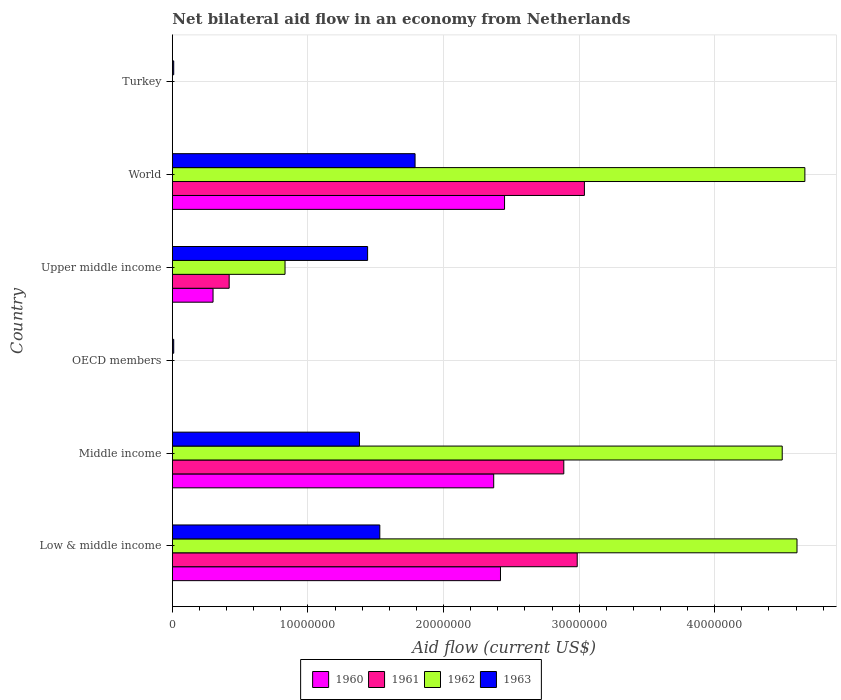How many different coloured bars are there?
Make the answer very short. 4. Are the number of bars on each tick of the Y-axis equal?
Give a very brief answer. No. How many bars are there on the 3rd tick from the bottom?
Offer a terse response. 1. What is the label of the 4th group of bars from the top?
Your response must be concise. OECD members. Across all countries, what is the maximum net bilateral aid flow in 1960?
Make the answer very short. 2.45e+07. Across all countries, what is the minimum net bilateral aid flow in 1960?
Provide a succinct answer. 0. In which country was the net bilateral aid flow in 1963 maximum?
Provide a short and direct response. World. What is the total net bilateral aid flow in 1960 in the graph?
Give a very brief answer. 7.54e+07. What is the difference between the net bilateral aid flow in 1963 in OECD members and that in Turkey?
Your answer should be very brief. 0. What is the difference between the net bilateral aid flow in 1963 in OECD members and the net bilateral aid flow in 1962 in Turkey?
Your response must be concise. 1.00e+05. What is the average net bilateral aid flow in 1961 per country?
Offer a terse response. 1.56e+07. What is the difference between the net bilateral aid flow in 1963 and net bilateral aid flow in 1960 in World?
Your response must be concise. -6.60e+06. In how many countries, is the net bilateral aid flow in 1962 greater than 34000000 US$?
Make the answer very short. 3. What is the ratio of the net bilateral aid flow in 1962 in Middle income to that in World?
Your answer should be very brief. 0.96. Is the net bilateral aid flow in 1962 in Low & middle income less than that in Upper middle income?
Your answer should be very brief. No. Is the difference between the net bilateral aid flow in 1963 in Middle income and World greater than the difference between the net bilateral aid flow in 1960 in Middle income and World?
Keep it short and to the point. No. What is the difference between the highest and the lowest net bilateral aid flow in 1962?
Your response must be concise. 4.66e+07. In how many countries, is the net bilateral aid flow in 1963 greater than the average net bilateral aid flow in 1963 taken over all countries?
Your answer should be compact. 4. Is it the case that in every country, the sum of the net bilateral aid flow in 1962 and net bilateral aid flow in 1960 is greater than the net bilateral aid flow in 1961?
Provide a succinct answer. No. How many bars are there?
Make the answer very short. 18. Are all the bars in the graph horizontal?
Offer a very short reply. Yes. Are the values on the major ticks of X-axis written in scientific E-notation?
Provide a succinct answer. No. Does the graph contain any zero values?
Offer a terse response. Yes. How are the legend labels stacked?
Provide a succinct answer. Horizontal. What is the title of the graph?
Your answer should be compact. Net bilateral aid flow in an economy from Netherlands. Does "1984" appear as one of the legend labels in the graph?
Make the answer very short. No. What is the Aid flow (current US$) in 1960 in Low & middle income?
Give a very brief answer. 2.42e+07. What is the Aid flow (current US$) of 1961 in Low & middle income?
Offer a very short reply. 2.99e+07. What is the Aid flow (current US$) in 1962 in Low & middle income?
Offer a very short reply. 4.61e+07. What is the Aid flow (current US$) of 1963 in Low & middle income?
Keep it short and to the point. 1.53e+07. What is the Aid flow (current US$) in 1960 in Middle income?
Ensure brevity in your answer.  2.37e+07. What is the Aid flow (current US$) of 1961 in Middle income?
Keep it short and to the point. 2.89e+07. What is the Aid flow (current US$) in 1962 in Middle income?
Ensure brevity in your answer.  4.50e+07. What is the Aid flow (current US$) of 1963 in Middle income?
Give a very brief answer. 1.38e+07. What is the Aid flow (current US$) in 1960 in OECD members?
Ensure brevity in your answer.  0. What is the Aid flow (current US$) in 1961 in OECD members?
Provide a short and direct response. 0. What is the Aid flow (current US$) of 1962 in OECD members?
Ensure brevity in your answer.  0. What is the Aid flow (current US$) of 1963 in OECD members?
Ensure brevity in your answer.  1.00e+05. What is the Aid flow (current US$) of 1961 in Upper middle income?
Give a very brief answer. 4.19e+06. What is the Aid flow (current US$) in 1962 in Upper middle income?
Your response must be concise. 8.31e+06. What is the Aid flow (current US$) of 1963 in Upper middle income?
Your answer should be very brief. 1.44e+07. What is the Aid flow (current US$) of 1960 in World?
Your response must be concise. 2.45e+07. What is the Aid flow (current US$) of 1961 in World?
Your response must be concise. 3.04e+07. What is the Aid flow (current US$) in 1962 in World?
Your answer should be very brief. 4.66e+07. What is the Aid flow (current US$) in 1963 in World?
Provide a succinct answer. 1.79e+07. What is the Aid flow (current US$) of 1961 in Turkey?
Your response must be concise. 0. What is the Aid flow (current US$) in 1962 in Turkey?
Give a very brief answer. 0. What is the Aid flow (current US$) of 1963 in Turkey?
Ensure brevity in your answer.  1.00e+05. Across all countries, what is the maximum Aid flow (current US$) in 1960?
Your answer should be very brief. 2.45e+07. Across all countries, what is the maximum Aid flow (current US$) of 1961?
Provide a succinct answer. 3.04e+07. Across all countries, what is the maximum Aid flow (current US$) of 1962?
Give a very brief answer. 4.66e+07. Across all countries, what is the maximum Aid flow (current US$) of 1963?
Ensure brevity in your answer.  1.79e+07. What is the total Aid flow (current US$) in 1960 in the graph?
Offer a very short reply. 7.54e+07. What is the total Aid flow (current US$) in 1961 in the graph?
Offer a terse response. 9.33e+07. What is the total Aid flow (current US$) in 1962 in the graph?
Offer a very short reply. 1.46e+08. What is the total Aid flow (current US$) in 1963 in the graph?
Provide a succinct answer. 6.16e+07. What is the difference between the Aid flow (current US$) of 1961 in Low & middle income and that in Middle income?
Keep it short and to the point. 9.90e+05. What is the difference between the Aid flow (current US$) in 1962 in Low & middle income and that in Middle income?
Your answer should be compact. 1.09e+06. What is the difference between the Aid flow (current US$) of 1963 in Low & middle income and that in Middle income?
Make the answer very short. 1.50e+06. What is the difference between the Aid flow (current US$) of 1963 in Low & middle income and that in OECD members?
Offer a very short reply. 1.52e+07. What is the difference between the Aid flow (current US$) in 1960 in Low & middle income and that in Upper middle income?
Offer a terse response. 2.12e+07. What is the difference between the Aid flow (current US$) in 1961 in Low & middle income and that in Upper middle income?
Make the answer very short. 2.57e+07. What is the difference between the Aid flow (current US$) in 1962 in Low & middle income and that in Upper middle income?
Offer a terse response. 3.78e+07. What is the difference between the Aid flow (current US$) in 1963 in Low & middle income and that in Upper middle income?
Offer a very short reply. 9.00e+05. What is the difference between the Aid flow (current US$) of 1961 in Low & middle income and that in World?
Your answer should be very brief. -5.30e+05. What is the difference between the Aid flow (current US$) in 1962 in Low & middle income and that in World?
Keep it short and to the point. -5.80e+05. What is the difference between the Aid flow (current US$) of 1963 in Low & middle income and that in World?
Give a very brief answer. -2.60e+06. What is the difference between the Aid flow (current US$) of 1963 in Low & middle income and that in Turkey?
Give a very brief answer. 1.52e+07. What is the difference between the Aid flow (current US$) in 1963 in Middle income and that in OECD members?
Provide a succinct answer. 1.37e+07. What is the difference between the Aid flow (current US$) of 1960 in Middle income and that in Upper middle income?
Make the answer very short. 2.07e+07. What is the difference between the Aid flow (current US$) in 1961 in Middle income and that in Upper middle income?
Offer a very short reply. 2.47e+07. What is the difference between the Aid flow (current US$) of 1962 in Middle income and that in Upper middle income?
Your answer should be compact. 3.67e+07. What is the difference between the Aid flow (current US$) of 1963 in Middle income and that in Upper middle income?
Offer a very short reply. -6.00e+05. What is the difference between the Aid flow (current US$) in 1960 in Middle income and that in World?
Make the answer very short. -8.00e+05. What is the difference between the Aid flow (current US$) of 1961 in Middle income and that in World?
Provide a succinct answer. -1.52e+06. What is the difference between the Aid flow (current US$) of 1962 in Middle income and that in World?
Keep it short and to the point. -1.67e+06. What is the difference between the Aid flow (current US$) of 1963 in Middle income and that in World?
Your answer should be very brief. -4.10e+06. What is the difference between the Aid flow (current US$) of 1963 in Middle income and that in Turkey?
Provide a short and direct response. 1.37e+07. What is the difference between the Aid flow (current US$) of 1963 in OECD members and that in Upper middle income?
Provide a short and direct response. -1.43e+07. What is the difference between the Aid flow (current US$) in 1963 in OECD members and that in World?
Provide a short and direct response. -1.78e+07. What is the difference between the Aid flow (current US$) of 1963 in OECD members and that in Turkey?
Provide a short and direct response. 0. What is the difference between the Aid flow (current US$) in 1960 in Upper middle income and that in World?
Keep it short and to the point. -2.15e+07. What is the difference between the Aid flow (current US$) of 1961 in Upper middle income and that in World?
Your answer should be compact. -2.62e+07. What is the difference between the Aid flow (current US$) in 1962 in Upper middle income and that in World?
Make the answer very short. -3.83e+07. What is the difference between the Aid flow (current US$) in 1963 in Upper middle income and that in World?
Offer a terse response. -3.50e+06. What is the difference between the Aid flow (current US$) of 1963 in Upper middle income and that in Turkey?
Keep it short and to the point. 1.43e+07. What is the difference between the Aid flow (current US$) in 1963 in World and that in Turkey?
Your response must be concise. 1.78e+07. What is the difference between the Aid flow (current US$) in 1960 in Low & middle income and the Aid flow (current US$) in 1961 in Middle income?
Your answer should be very brief. -4.67e+06. What is the difference between the Aid flow (current US$) of 1960 in Low & middle income and the Aid flow (current US$) of 1962 in Middle income?
Offer a very short reply. -2.08e+07. What is the difference between the Aid flow (current US$) of 1960 in Low & middle income and the Aid flow (current US$) of 1963 in Middle income?
Make the answer very short. 1.04e+07. What is the difference between the Aid flow (current US$) of 1961 in Low & middle income and the Aid flow (current US$) of 1962 in Middle income?
Your response must be concise. -1.51e+07. What is the difference between the Aid flow (current US$) of 1961 in Low & middle income and the Aid flow (current US$) of 1963 in Middle income?
Your answer should be compact. 1.61e+07. What is the difference between the Aid flow (current US$) in 1962 in Low & middle income and the Aid flow (current US$) in 1963 in Middle income?
Make the answer very short. 3.23e+07. What is the difference between the Aid flow (current US$) of 1960 in Low & middle income and the Aid flow (current US$) of 1963 in OECD members?
Provide a succinct answer. 2.41e+07. What is the difference between the Aid flow (current US$) of 1961 in Low & middle income and the Aid flow (current US$) of 1963 in OECD members?
Make the answer very short. 2.98e+07. What is the difference between the Aid flow (current US$) of 1962 in Low & middle income and the Aid flow (current US$) of 1963 in OECD members?
Your answer should be very brief. 4.60e+07. What is the difference between the Aid flow (current US$) of 1960 in Low & middle income and the Aid flow (current US$) of 1961 in Upper middle income?
Ensure brevity in your answer.  2.00e+07. What is the difference between the Aid flow (current US$) of 1960 in Low & middle income and the Aid flow (current US$) of 1962 in Upper middle income?
Offer a very short reply. 1.59e+07. What is the difference between the Aid flow (current US$) in 1960 in Low & middle income and the Aid flow (current US$) in 1963 in Upper middle income?
Ensure brevity in your answer.  9.80e+06. What is the difference between the Aid flow (current US$) in 1961 in Low & middle income and the Aid flow (current US$) in 1962 in Upper middle income?
Your response must be concise. 2.16e+07. What is the difference between the Aid flow (current US$) of 1961 in Low & middle income and the Aid flow (current US$) of 1963 in Upper middle income?
Provide a succinct answer. 1.55e+07. What is the difference between the Aid flow (current US$) in 1962 in Low & middle income and the Aid flow (current US$) in 1963 in Upper middle income?
Keep it short and to the point. 3.17e+07. What is the difference between the Aid flow (current US$) of 1960 in Low & middle income and the Aid flow (current US$) of 1961 in World?
Give a very brief answer. -6.19e+06. What is the difference between the Aid flow (current US$) of 1960 in Low & middle income and the Aid flow (current US$) of 1962 in World?
Keep it short and to the point. -2.24e+07. What is the difference between the Aid flow (current US$) in 1960 in Low & middle income and the Aid flow (current US$) in 1963 in World?
Your answer should be very brief. 6.30e+06. What is the difference between the Aid flow (current US$) in 1961 in Low & middle income and the Aid flow (current US$) in 1962 in World?
Offer a very short reply. -1.68e+07. What is the difference between the Aid flow (current US$) of 1961 in Low & middle income and the Aid flow (current US$) of 1963 in World?
Provide a short and direct response. 1.20e+07. What is the difference between the Aid flow (current US$) of 1962 in Low & middle income and the Aid flow (current US$) of 1963 in World?
Offer a terse response. 2.82e+07. What is the difference between the Aid flow (current US$) of 1960 in Low & middle income and the Aid flow (current US$) of 1963 in Turkey?
Keep it short and to the point. 2.41e+07. What is the difference between the Aid flow (current US$) in 1961 in Low & middle income and the Aid flow (current US$) in 1963 in Turkey?
Provide a short and direct response. 2.98e+07. What is the difference between the Aid flow (current US$) in 1962 in Low & middle income and the Aid flow (current US$) in 1963 in Turkey?
Your answer should be compact. 4.60e+07. What is the difference between the Aid flow (current US$) of 1960 in Middle income and the Aid flow (current US$) of 1963 in OECD members?
Your answer should be compact. 2.36e+07. What is the difference between the Aid flow (current US$) of 1961 in Middle income and the Aid flow (current US$) of 1963 in OECD members?
Make the answer very short. 2.88e+07. What is the difference between the Aid flow (current US$) of 1962 in Middle income and the Aid flow (current US$) of 1963 in OECD members?
Offer a terse response. 4.49e+07. What is the difference between the Aid flow (current US$) of 1960 in Middle income and the Aid flow (current US$) of 1961 in Upper middle income?
Give a very brief answer. 1.95e+07. What is the difference between the Aid flow (current US$) in 1960 in Middle income and the Aid flow (current US$) in 1962 in Upper middle income?
Offer a terse response. 1.54e+07. What is the difference between the Aid flow (current US$) of 1960 in Middle income and the Aid flow (current US$) of 1963 in Upper middle income?
Make the answer very short. 9.30e+06. What is the difference between the Aid flow (current US$) of 1961 in Middle income and the Aid flow (current US$) of 1962 in Upper middle income?
Give a very brief answer. 2.06e+07. What is the difference between the Aid flow (current US$) of 1961 in Middle income and the Aid flow (current US$) of 1963 in Upper middle income?
Provide a short and direct response. 1.45e+07. What is the difference between the Aid flow (current US$) in 1962 in Middle income and the Aid flow (current US$) in 1963 in Upper middle income?
Provide a short and direct response. 3.06e+07. What is the difference between the Aid flow (current US$) of 1960 in Middle income and the Aid flow (current US$) of 1961 in World?
Keep it short and to the point. -6.69e+06. What is the difference between the Aid flow (current US$) of 1960 in Middle income and the Aid flow (current US$) of 1962 in World?
Your response must be concise. -2.30e+07. What is the difference between the Aid flow (current US$) of 1960 in Middle income and the Aid flow (current US$) of 1963 in World?
Provide a short and direct response. 5.80e+06. What is the difference between the Aid flow (current US$) in 1961 in Middle income and the Aid flow (current US$) in 1962 in World?
Make the answer very short. -1.78e+07. What is the difference between the Aid flow (current US$) in 1961 in Middle income and the Aid flow (current US$) in 1963 in World?
Ensure brevity in your answer.  1.10e+07. What is the difference between the Aid flow (current US$) in 1962 in Middle income and the Aid flow (current US$) in 1963 in World?
Give a very brief answer. 2.71e+07. What is the difference between the Aid flow (current US$) in 1960 in Middle income and the Aid flow (current US$) in 1963 in Turkey?
Your answer should be compact. 2.36e+07. What is the difference between the Aid flow (current US$) of 1961 in Middle income and the Aid flow (current US$) of 1963 in Turkey?
Give a very brief answer. 2.88e+07. What is the difference between the Aid flow (current US$) in 1962 in Middle income and the Aid flow (current US$) in 1963 in Turkey?
Offer a very short reply. 4.49e+07. What is the difference between the Aid flow (current US$) of 1960 in Upper middle income and the Aid flow (current US$) of 1961 in World?
Ensure brevity in your answer.  -2.74e+07. What is the difference between the Aid flow (current US$) in 1960 in Upper middle income and the Aid flow (current US$) in 1962 in World?
Your answer should be very brief. -4.36e+07. What is the difference between the Aid flow (current US$) of 1960 in Upper middle income and the Aid flow (current US$) of 1963 in World?
Offer a very short reply. -1.49e+07. What is the difference between the Aid flow (current US$) of 1961 in Upper middle income and the Aid flow (current US$) of 1962 in World?
Give a very brief answer. -4.25e+07. What is the difference between the Aid flow (current US$) in 1961 in Upper middle income and the Aid flow (current US$) in 1963 in World?
Ensure brevity in your answer.  -1.37e+07. What is the difference between the Aid flow (current US$) in 1962 in Upper middle income and the Aid flow (current US$) in 1963 in World?
Provide a short and direct response. -9.59e+06. What is the difference between the Aid flow (current US$) of 1960 in Upper middle income and the Aid flow (current US$) of 1963 in Turkey?
Your answer should be compact. 2.90e+06. What is the difference between the Aid flow (current US$) of 1961 in Upper middle income and the Aid flow (current US$) of 1963 in Turkey?
Offer a terse response. 4.09e+06. What is the difference between the Aid flow (current US$) of 1962 in Upper middle income and the Aid flow (current US$) of 1963 in Turkey?
Provide a succinct answer. 8.21e+06. What is the difference between the Aid flow (current US$) of 1960 in World and the Aid flow (current US$) of 1963 in Turkey?
Your answer should be very brief. 2.44e+07. What is the difference between the Aid flow (current US$) of 1961 in World and the Aid flow (current US$) of 1963 in Turkey?
Provide a short and direct response. 3.03e+07. What is the difference between the Aid flow (current US$) in 1962 in World and the Aid flow (current US$) in 1963 in Turkey?
Your answer should be very brief. 4.66e+07. What is the average Aid flow (current US$) of 1960 per country?
Offer a terse response. 1.26e+07. What is the average Aid flow (current US$) in 1961 per country?
Your answer should be compact. 1.56e+07. What is the average Aid flow (current US$) of 1962 per country?
Give a very brief answer. 2.43e+07. What is the average Aid flow (current US$) of 1963 per country?
Your answer should be very brief. 1.03e+07. What is the difference between the Aid flow (current US$) in 1960 and Aid flow (current US$) in 1961 in Low & middle income?
Your response must be concise. -5.66e+06. What is the difference between the Aid flow (current US$) of 1960 and Aid flow (current US$) of 1962 in Low & middle income?
Offer a terse response. -2.19e+07. What is the difference between the Aid flow (current US$) of 1960 and Aid flow (current US$) of 1963 in Low & middle income?
Ensure brevity in your answer.  8.90e+06. What is the difference between the Aid flow (current US$) in 1961 and Aid flow (current US$) in 1962 in Low & middle income?
Your answer should be very brief. -1.62e+07. What is the difference between the Aid flow (current US$) of 1961 and Aid flow (current US$) of 1963 in Low & middle income?
Keep it short and to the point. 1.46e+07. What is the difference between the Aid flow (current US$) of 1962 and Aid flow (current US$) of 1963 in Low & middle income?
Your answer should be compact. 3.08e+07. What is the difference between the Aid flow (current US$) of 1960 and Aid flow (current US$) of 1961 in Middle income?
Your answer should be very brief. -5.17e+06. What is the difference between the Aid flow (current US$) of 1960 and Aid flow (current US$) of 1962 in Middle income?
Provide a short and direct response. -2.13e+07. What is the difference between the Aid flow (current US$) of 1960 and Aid flow (current US$) of 1963 in Middle income?
Provide a succinct answer. 9.90e+06. What is the difference between the Aid flow (current US$) of 1961 and Aid flow (current US$) of 1962 in Middle income?
Keep it short and to the point. -1.61e+07. What is the difference between the Aid flow (current US$) of 1961 and Aid flow (current US$) of 1963 in Middle income?
Offer a terse response. 1.51e+07. What is the difference between the Aid flow (current US$) of 1962 and Aid flow (current US$) of 1963 in Middle income?
Provide a short and direct response. 3.12e+07. What is the difference between the Aid flow (current US$) of 1960 and Aid flow (current US$) of 1961 in Upper middle income?
Offer a terse response. -1.19e+06. What is the difference between the Aid flow (current US$) of 1960 and Aid flow (current US$) of 1962 in Upper middle income?
Provide a succinct answer. -5.31e+06. What is the difference between the Aid flow (current US$) of 1960 and Aid flow (current US$) of 1963 in Upper middle income?
Make the answer very short. -1.14e+07. What is the difference between the Aid flow (current US$) in 1961 and Aid flow (current US$) in 1962 in Upper middle income?
Provide a short and direct response. -4.12e+06. What is the difference between the Aid flow (current US$) in 1961 and Aid flow (current US$) in 1963 in Upper middle income?
Offer a terse response. -1.02e+07. What is the difference between the Aid flow (current US$) of 1962 and Aid flow (current US$) of 1963 in Upper middle income?
Offer a terse response. -6.09e+06. What is the difference between the Aid flow (current US$) of 1960 and Aid flow (current US$) of 1961 in World?
Make the answer very short. -5.89e+06. What is the difference between the Aid flow (current US$) of 1960 and Aid flow (current US$) of 1962 in World?
Make the answer very short. -2.22e+07. What is the difference between the Aid flow (current US$) of 1960 and Aid flow (current US$) of 1963 in World?
Make the answer very short. 6.60e+06. What is the difference between the Aid flow (current US$) of 1961 and Aid flow (current US$) of 1962 in World?
Keep it short and to the point. -1.63e+07. What is the difference between the Aid flow (current US$) in 1961 and Aid flow (current US$) in 1963 in World?
Keep it short and to the point. 1.25e+07. What is the difference between the Aid flow (current US$) in 1962 and Aid flow (current US$) in 1963 in World?
Make the answer very short. 2.88e+07. What is the ratio of the Aid flow (current US$) of 1960 in Low & middle income to that in Middle income?
Provide a succinct answer. 1.02. What is the ratio of the Aid flow (current US$) of 1961 in Low & middle income to that in Middle income?
Make the answer very short. 1.03. What is the ratio of the Aid flow (current US$) of 1962 in Low & middle income to that in Middle income?
Provide a succinct answer. 1.02. What is the ratio of the Aid flow (current US$) of 1963 in Low & middle income to that in Middle income?
Make the answer very short. 1.11. What is the ratio of the Aid flow (current US$) of 1963 in Low & middle income to that in OECD members?
Provide a succinct answer. 153. What is the ratio of the Aid flow (current US$) of 1960 in Low & middle income to that in Upper middle income?
Make the answer very short. 8.07. What is the ratio of the Aid flow (current US$) of 1961 in Low & middle income to that in Upper middle income?
Provide a short and direct response. 7.13. What is the ratio of the Aid flow (current US$) of 1962 in Low & middle income to that in Upper middle income?
Your response must be concise. 5.54. What is the ratio of the Aid flow (current US$) in 1963 in Low & middle income to that in Upper middle income?
Make the answer very short. 1.06. What is the ratio of the Aid flow (current US$) in 1961 in Low & middle income to that in World?
Your response must be concise. 0.98. What is the ratio of the Aid flow (current US$) of 1962 in Low & middle income to that in World?
Make the answer very short. 0.99. What is the ratio of the Aid flow (current US$) of 1963 in Low & middle income to that in World?
Offer a very short reply. 0.85. What is the ratio of the Aid flow (current US$) of 1963 in Low & middle income to that in Turkey?
Keep it short and to the point. 153. What is the ratio of the Aid flow (current US$) in 1963 in Middle income to that in OECD members?
Give a very brief answer. 138. What is the ratio of the Aid flow (current US$) in 1960 in Middle income to that in Upper middle income?
Keep it short and to the point. 7.9. What is the ratio of the Aid flow (current US$) in 1961 in Middle income to that in Upper middle income?
Give a very brief answer. 6.89. What is the ratio of the Aid flow (current US$) in 1962 in Middle income to that in Upper middle income?
Give a very brief answer. 5.41. What is the ratio of the Aid flow (current US$) in 1960 in Middle income to that in World?
Your response must be concise. 0.97. What is the ratio of the Aid flow (current US$) in 1962 in Middle income to that in World?
Make the answer very short. 0.96. What is the ratio of the Aid flow (current US$) of 1963 in Middle income to that in World?
Make the answer very short. 0.77. What is the ratio of the Aid flow (current US$) in 1963 in Middle income to that in Turkey?
Give a very brief answer. 138. What is the ratio of the Aid flow (current US$) in 1963 in OECD members to that in Upper middle income?
Ensure brevity in your answer.  0.01. What is the ratio of the Aid flow (current US$) in 1963 in OECD members to that in World?
Give a very brief answer. 0.01. What is the ratio of the Aid flow (current US$) in 1963 in OECD members to that in Turkey?
Give a very brief answer. 1. What is the ratio of the Aid flow (current US$) in 1960 in Upper middle income to that in World?
Make the answer very short. 0.12. What is the ratio of the Aid flow (current US$) in 1961 in Upper middle income to that in World?
Your answer should be very brief. 0.14. What is the ratio of the Aid flow (current US$) in 1962 in Upper middle income to that in World?
Your answer should be very brief. 0.18. What is the ratio of the Aid flow (current US$) in 1963 in Upper middle income to that in World?
Your response must be concise. 0.8. What is the ratio of the Aid flow (current US$) of 1963 in Upper middle income to that in Turkey?
Your answer should be very brief. 144. What is the ratio of the Aid flow (current US$) of 1963 in World to that in Turkey?
Your answer should be very brief. 179. What is the difference between the highest and the second highest Aid flow (current US$) in 1961?
Offer a very short reply. 5.30e+05. What is the difference between the highest and the second highest Aid flow (current US$) of 1962?
Make the answer very short. 5.80e+05. What is the difference between the highest and the second highest Aid flow (current US$) in 1963?
Provide a short and direct response. 2.60e+06. What is the difference between the highest and the lowest Aid flow (current US$) in 1960?
Keep it short and to the point. 2.45e+07. What is the difference between the highest and the lowest Aid flow (current US$) of 1961?
Your answer should be very brief. 3.04e+07. What is the difference between the highest and the lowest Aid flow (current US$) of 1962?
Keep it short and to the point. 4.66e+07. What is the difference between the highest and the lowest Aid flow (current US$) of 1963?
Provide a succinct answer. 1.78e+07. 